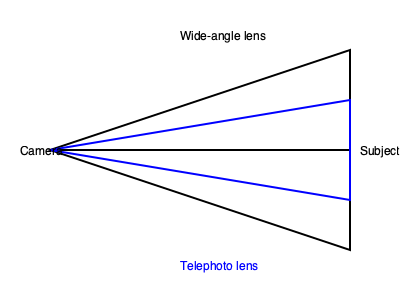Based on the diagram, which lens type provides a wider field of view and which typically has a shallower depth of field when shooting at the same aperture? 1. Field of View:
   - The black lines represent a wide-angle lens, showing a broader angle from the camera to the subject.
   - The blue lines represent a telephoto lens, showing a narrower angle.
   - Wide-angle lenses have a wider field of view, capturing more of the scene.

2. Depth of Field:
   - Depth of field refers to the range of distance that appears acceptably sharp in an image.
   - At the same aperture, telephoto lenses typically have a shallower depth of field compared to wide-angle lenses.
   - This is due to the compression effect of telephoto lenses, which magnifies the background more than wide-angle lenses.

3. Lens Characteristics:
   - Wide-angle lenses: Wider field of view, generally deeper depth of field.
   - Telephoto lenses: Narrower field of view, generally shallower depth of field.

4. Practical Application:
   - In a movie theater setting, wide-angle lenses might be used for establishing shots or in confined spaces.
   - Telephoto lenses might be used for close-ups or to create a shallow depth of field for artistic effect.

Therefore, the wide-angle lens (black lines) provides a wider field of view, while the telephoto lens (blue lines) typically has a shallower depth of field when shooting at the same aperture.
Answer: Wide-angle: wider field of view; Telephoto: shallower depth of field 